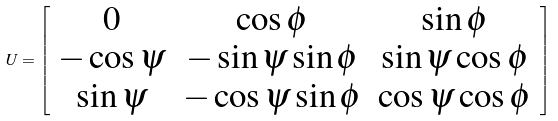Convert formula to latex. <formula><loc_0><loc_0><loc_500><loc_500>U = \left [ \begin{array} { c c c } 0 & \cos \phi & \sin \phi \\ - \cos \psi & - \sin \psi \sin \phi & \sin \psi \cos \phi \\ \sin \psi & - \cos \psi \sin \phi & \cos \psi \cos \phi \end{array} \right ]</formula> 